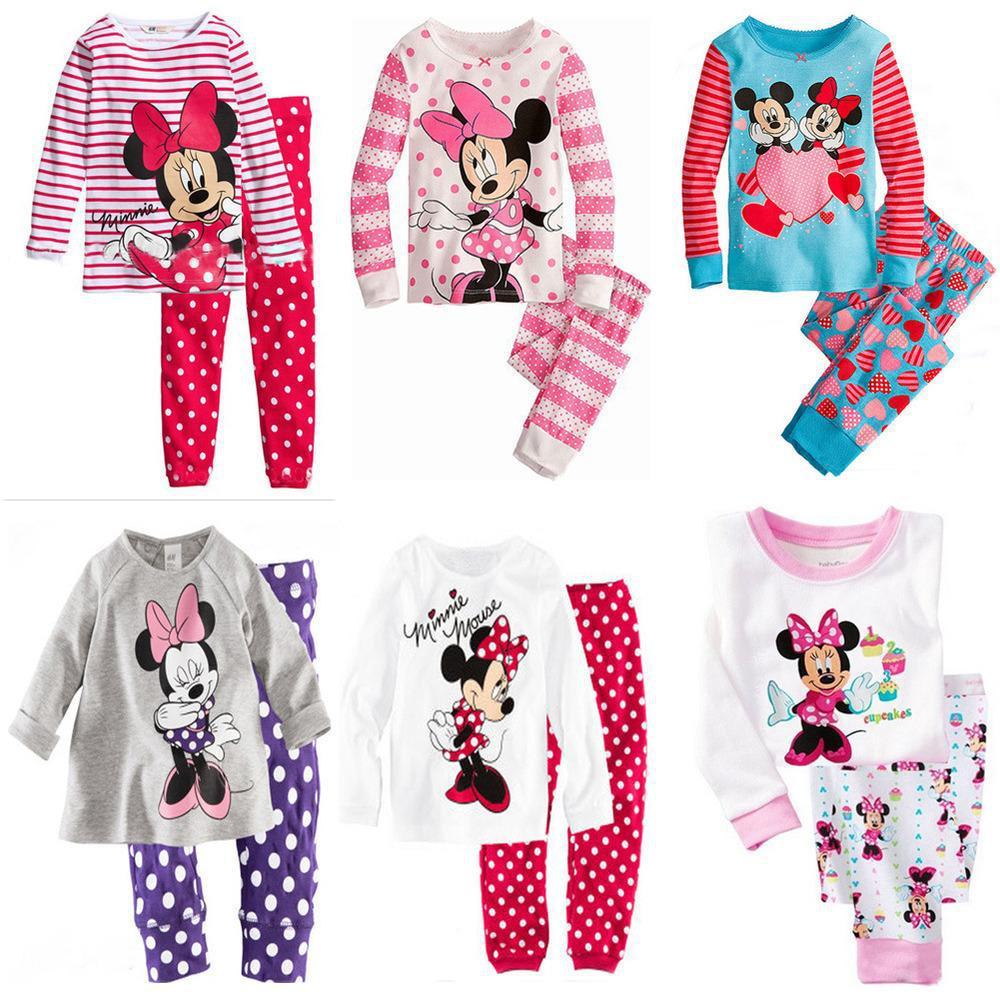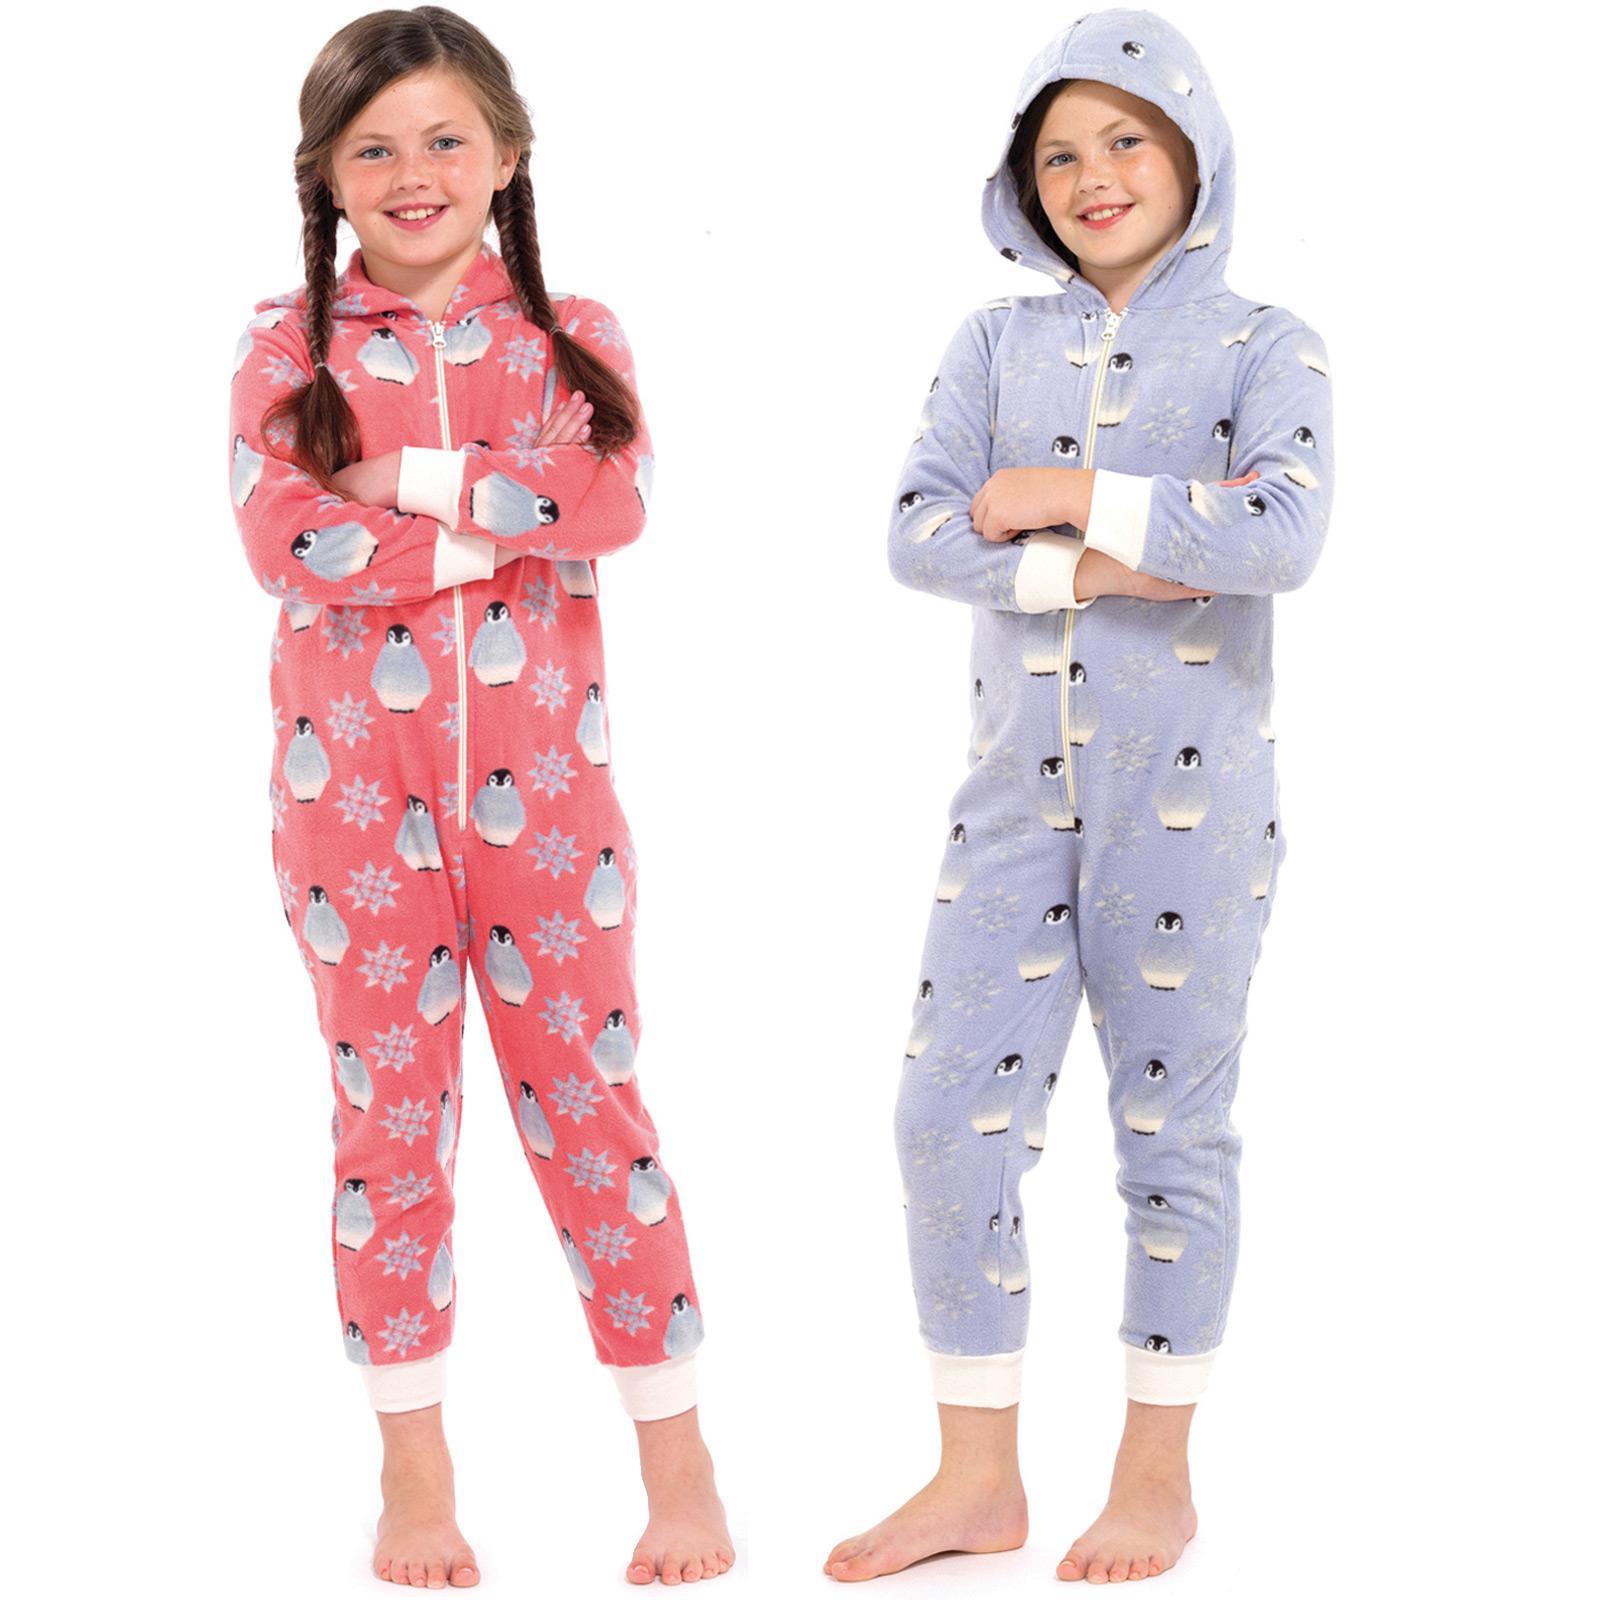The first image is the image on the left, the second image is the image on the right. Considering the images on both sides, is "There is more than one child in total." valid? Answer yes or no. Yes. The first image is the image on the left, the second image is the image on the right. Examine the images to the left and right. Is the description "At least 1 child is wearing blue patterned pajamas." accurate? Answer yes or no. Yes. 